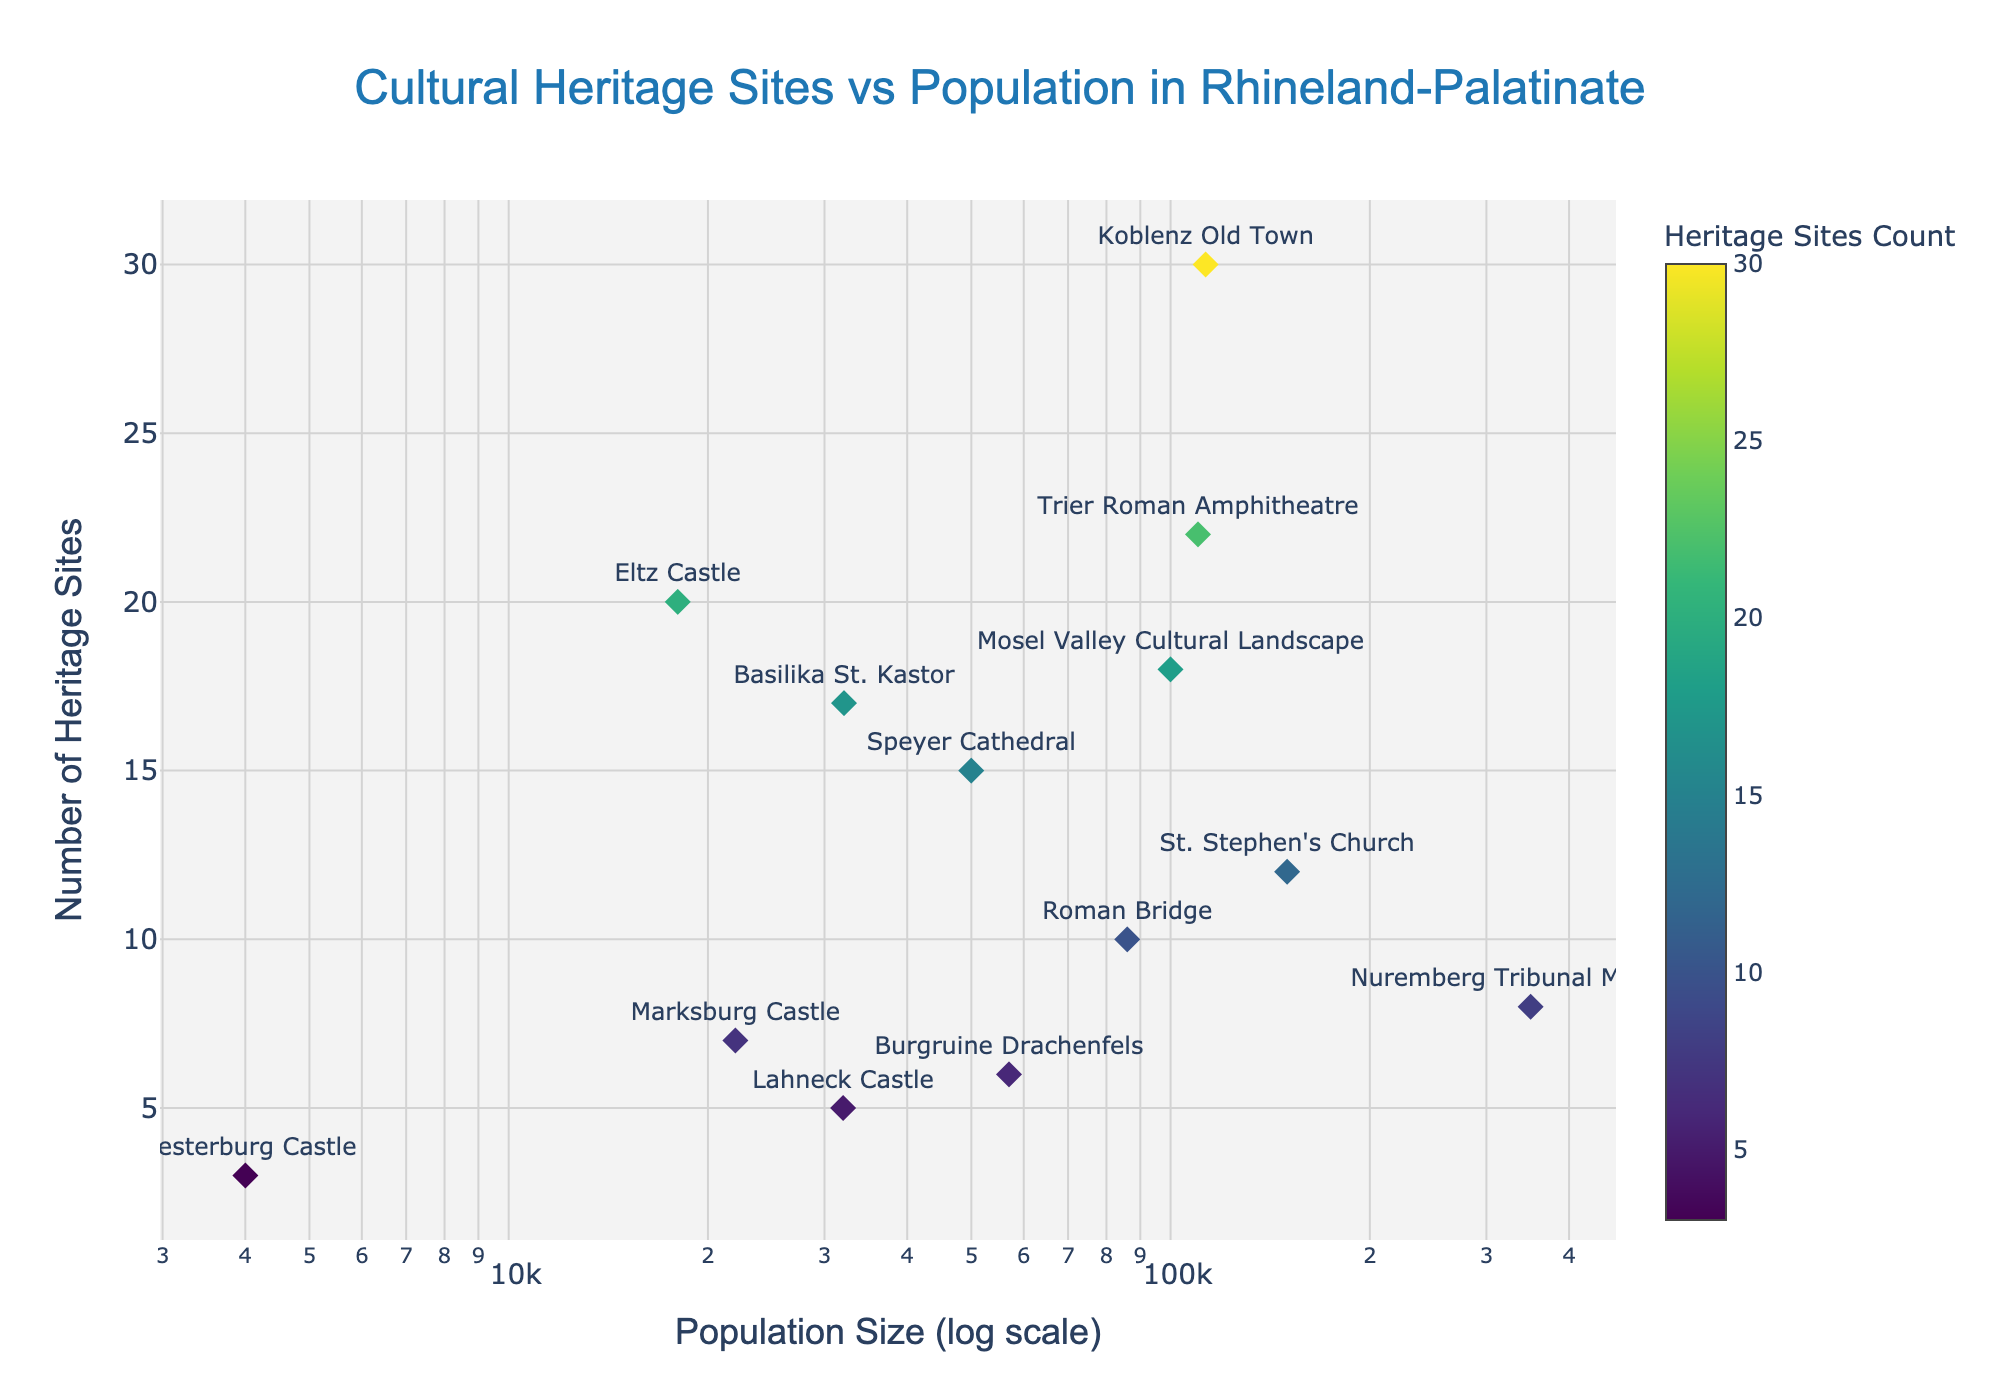What is the total number of data points shown in the scatter plot? Count the number of markers (points) in the figure. Each marker represents a data point.
Answer: 13 Which heritage site has the highest number of cultural heritage counts? Identify the marker with the highest y-axis value 'heritage_counts', then check the corresponding site name in the hover text or marker's label.
Answer: Trier Roman Amphitheatre What is the population size of Speyer Cathedral? Find the marker labeled "Speyer Cathedral" and check its corresponding x-axis value for population size from the hover text or marker's position on the x-axis.
Answer: 50,000 How many heritage sites have a population size greater than 100,000? Count the number of markers where the x-axis value (population size) is greater than 100,000.
Answer: 5 What is the average heritage count of the sites with a population size less than 50,000? Identify the markers with population sizes less than 50,000, sum their heritage counts, and divide by the number of these markers.
Answer: (20 + 5 + 7 + 3 + 17 + 6)/6 = 9.67 Which heritage site has the smallest population size and what is its heritage count? Identify the marker with the smallest x-axis value (population size), then check the corresponding site name and its y-axis value from the hover text or marker label.
Answer: Westerburg Castle, 3 Which location has a higher number of heritage sites: Koblenz Old Town or Mosel Valley Cultural Landscape? Compare the y-axis values (heritage counts) of markers labeled "Koblenz Old Town" and "Mosel Valley Cultural Landscape."
Answer: Koblenz Old Town What is the difference in heritage counts between St. Stephen's Church and Roman Bridge? Find the y-axis values (heritage counts) for both markers and calculate the difference.
Answer: 12 - 10 = 2 Do the majority of sites with more than 15 heritage counts belong to locations with populations greater than 100,000? Identify sites with heritage counts greater than 15, then check the population sizes of those sites to see if most are greater than 100,000.
Answer: No What trends do you observe about the distribution of cultural heritage sites in relation to the population size on a log scale? Look for patterns in how the points are distributed. Consider if higher populations often correlate with higher heritage counts or if there's a diverse spread.
Answer: High population doesn't necessarily equate to higher heritage counts; there's a varying distribution 